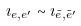<formula> <loc_0><loc_0><loc_500><loc_500>\imath _ { e , e ^ { \prime } } \sim \imath _ { \tilde { e } , \tilde { e } ^ { \prime } }</formula> 